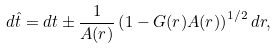<formula> <loc_0><loc_0><loc_500><loc_500>d \hat { t } = d t \pm \frac { 1 } { A ( r ) } \left ( 1 - G ( r ) A ( r ) \right ) ^ { 1 / 2 } d r ,</formula> 